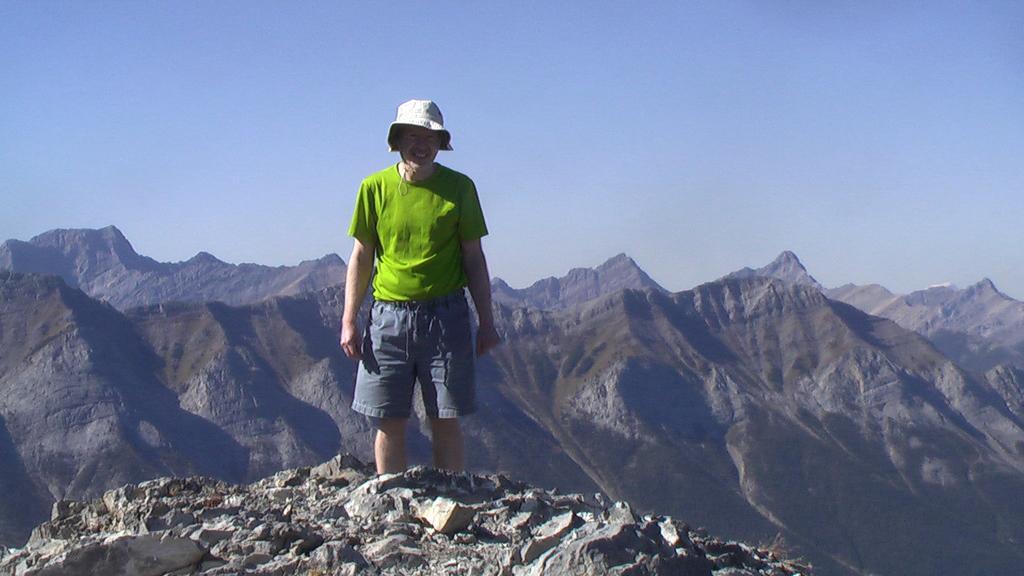Please provide a concise description of this image. In the center of the image we can see one person is standing and he is smiling. And we can see he is wearing a hat and he is in green t shirt. At the bottom of the image, we can see the stones. In the background we can see the sky and hills. 